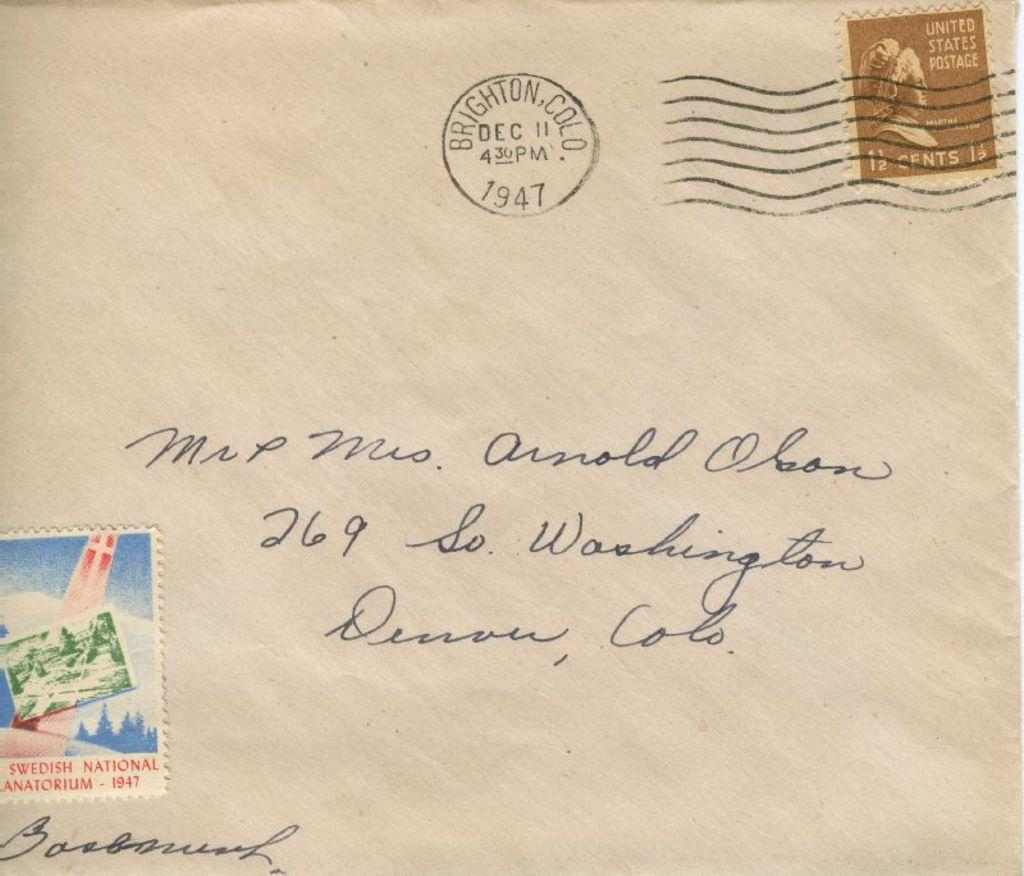<image>
Give a short and clear explanation of the subsequent image. Letter with a stamp which says United States Postage. 